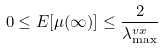<formula> <loc_0><loc_0><loc_500><loc_500>0 \leq E [ \mu ( \infty ) ] \leq \frac { 2 } { \lambda ^ { v x } _ { \max } }</formula> 